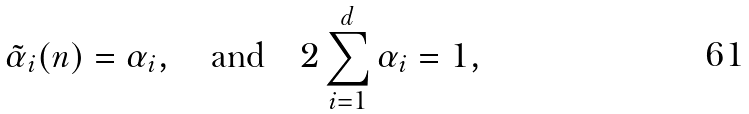Convert formula to latex. <formula><loc_0><loc_0><loc_500><loc_500>\tilde { \alpha } _ { i } ( n ) = \alpha _ { i } , \quad \text {and} \quad 2 \sum _ { i = 1 } ^ { d } \alpha _ { i } = 1 ,</formula> 